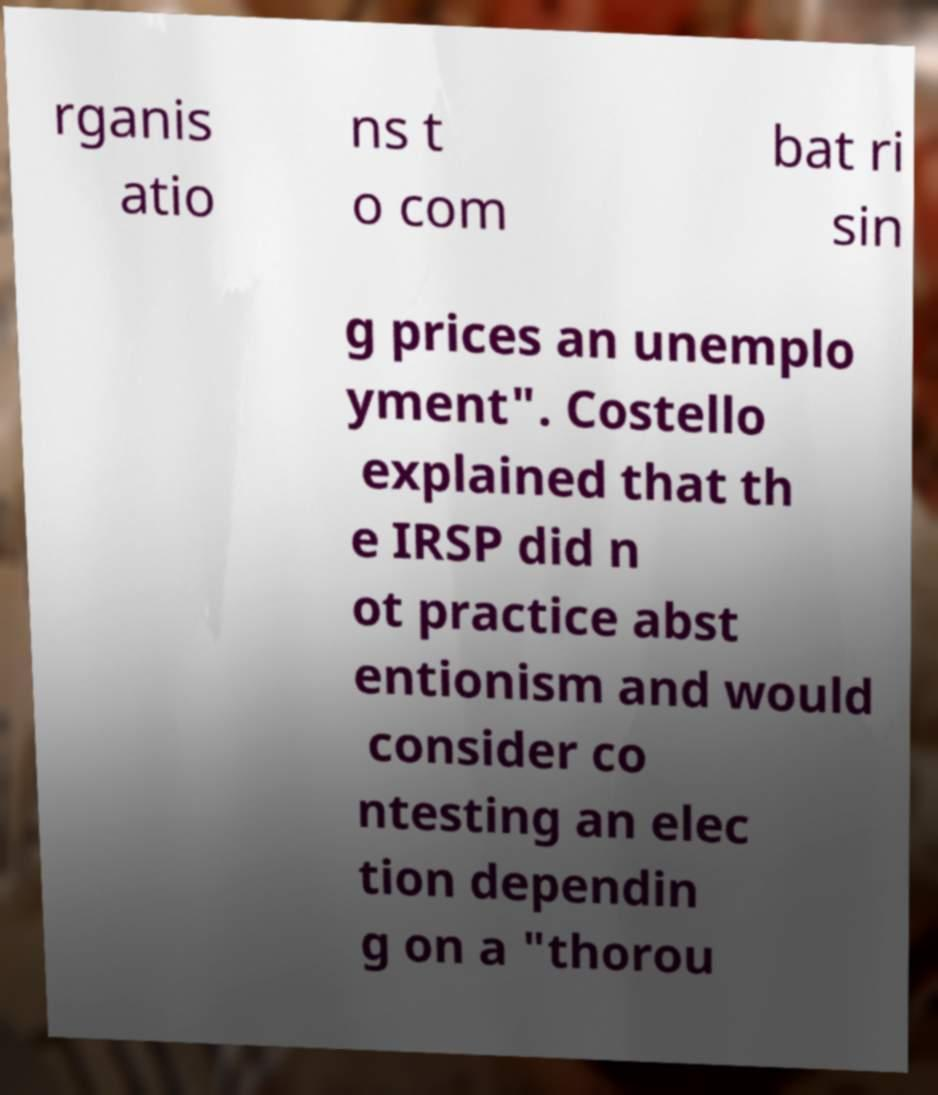For documentation purposes, I need the text within this image transcribed. Could you provide that? rganis atio ns t o com bat ri sin g prices an unemplo yment". Costello explained that th e IRSP did n ot practice abst entionism and would consider co ntesting an elec tion dependin g on a "thorou 